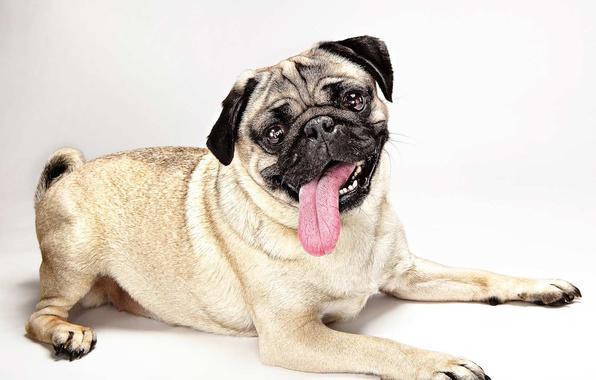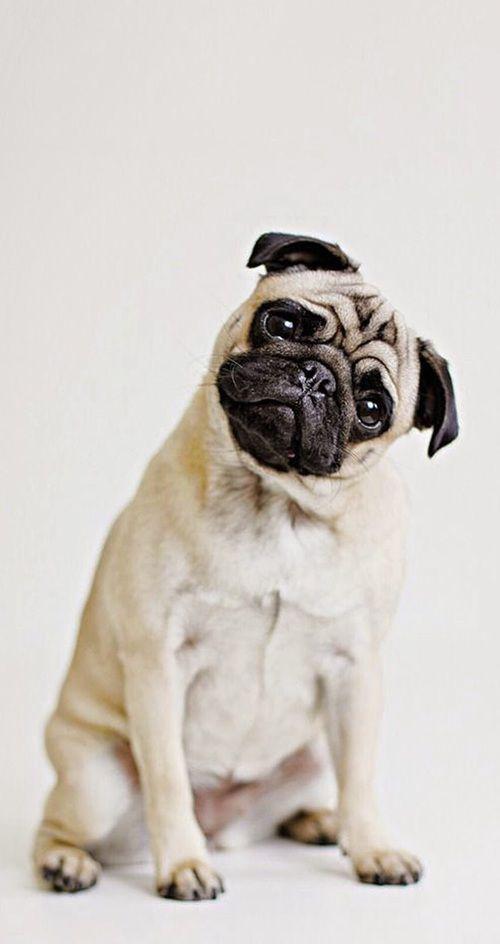The first image is the image on the left, the second image is the image on the right. For the images displayed, is the sentence "There are three or fewer dogs in total." factually correct? Answer yes or no. Yes. The first image is the image on the left, the second image is the image on the right. Given the left and right images, does the statement "The right image contains at least two dogs." hold true? Answer yes or no. No. 